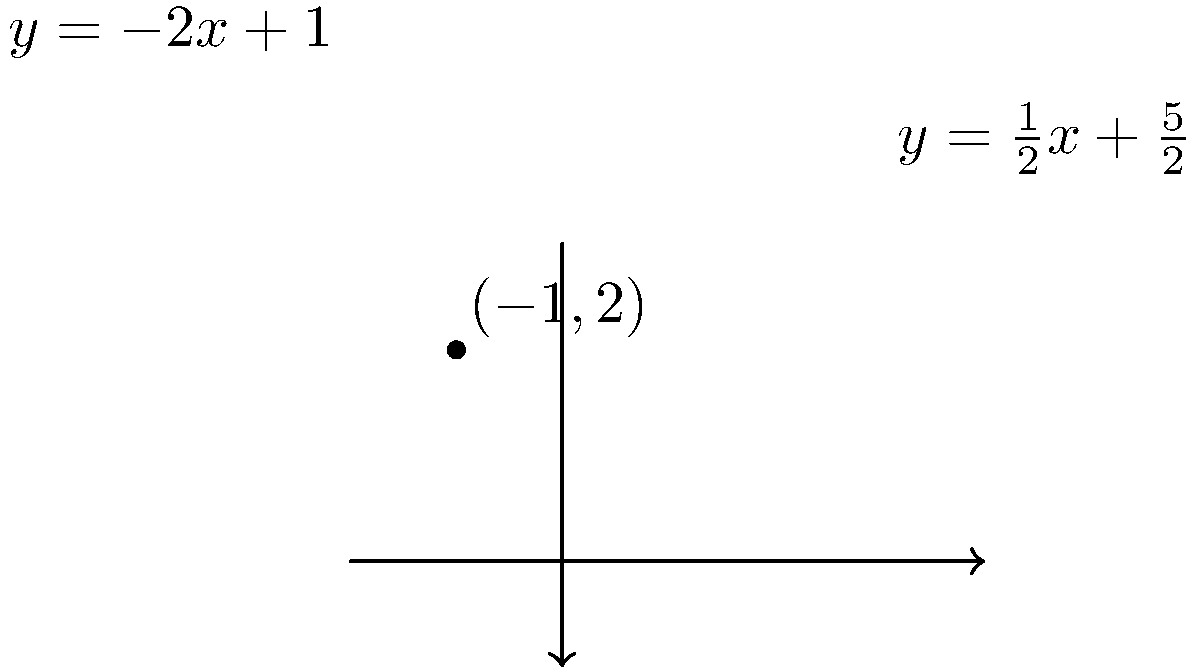During a town meeting discussing traffic safety, you need to determine the exact location where Main Street and Oak Avenue intersect. Main Street can be represented by the equation $y=\frac{1}{2}x+\frac{5}{2}$, while Oak Avenue follows the equation $y=-2x+1$. What are the coordinates of the intersection point? To find the intersection point of the two streets, we need to solve the system of equations:

1) First equation (Main Street): $y=\frac{1}{2}x+\frac{5}{2}$
2) Second equation (Oak Avenue): $y=-2x+1$

Step 1: Set the two equations equal to each other:
$$\frac{1}{2}x+\frac{5}{2} = -2x+1$$

Step 2: Solve for x:
$$\frac{1}{2}x+\frac{5}{2} = -2x+1$$
$$\frac{1}{2}x+2x = 1-\frac{5}{2}$$
$$\frac{5}{2}x = -\frac{3}{2}$$
$$x = -\frac{3}{5} = -0.6$$

Step 3: Substitute this x-value into either of the original equations. Let's use the first one:
$$y = \frac{1}{2}(-0.6)+\frac{5}{2}$$
$$y = -0.3+\frac{5}{2} = 2.2$$

Therefore, the intersection point is $(-0.6, 2.2)$.
Answer: $(-0.6, 2.2)$ 